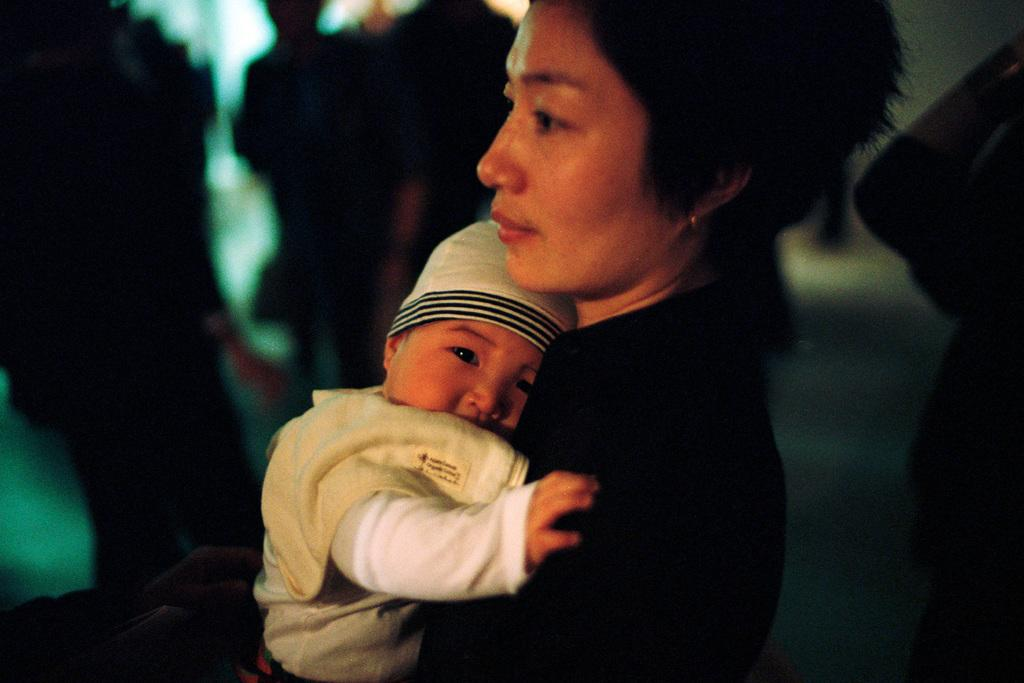Who is the main subject in the image? There is a lady in the image. What is the lady doing in the image? The lady is holding a small baby. Can you describe the people in the background of the image? There are other people in the background of the image. What type of meal is being prepared by the grandmother in the image? There is no grandmother or meal preparation visible in the image. 